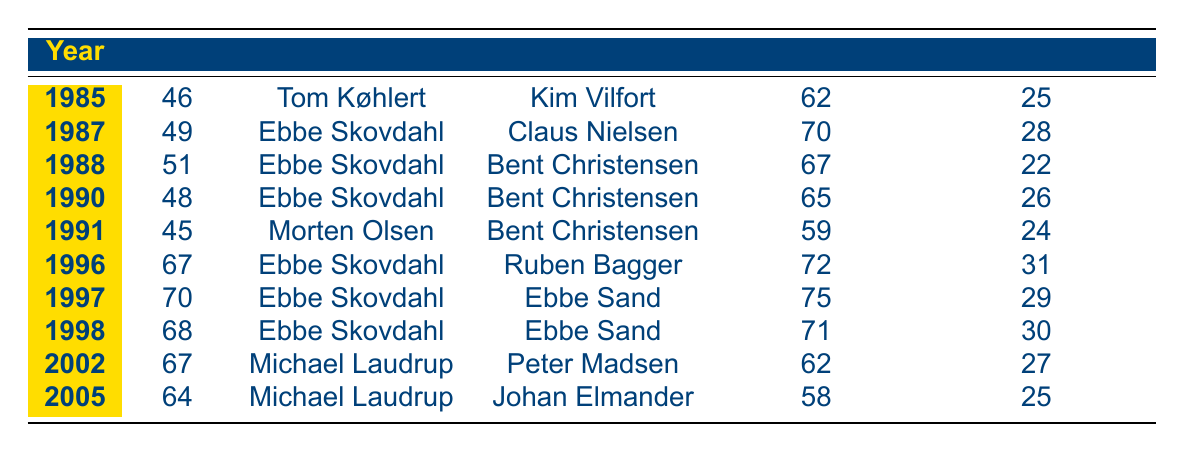What year did Brøndby IF score the highest points in the Danish Superliga? By inspecting the table, we can see the points scored for each year. The highest points are 70, which occurred in 1997.
Answer: 1997 Who was the top scorer for Brøndby IF in 1988? The table lists "Bent Christensen" as the top scorer for the year 1988 under the Top Scorer column.
Answer: Bent Christensen How many titles did Brøndby IF win under manager Ebbe Skovdahl? By counting the entries in the table, we see that under Ebbe Skovdahl, Brøndby IF won titles in 1987, 1988, 1990, 1996, 1997, and 1998, totaling six titles.
Answer: 6 What is the average number of points scored in the title-winning years? To find the average, we sum the points scored: 46 + 49 + 51 + 48 + 45 + 67 + 70 + 68 + 67 + 64 =  496. There are 10 years in total, so the average points are 496 / 10 = 49.6.
Answer: 49.6 Was the number of goals scored higher in 1996 than in 2005? In 1996, Brøndby IF scored 72 goals, while in 2005, they scored 58 goals. Since 72 is greater than 58, the answer is yes.
Answer: Yes What is the difference in points scored between the years 1985 and 1991? From the table, 1985 has 46 points and 1991 has 45 points. Therefore, the difference is 46 - 45 = 1.
Answer: 1 In which year did Brøndby IF concede the fewest goals? By reviewing the Goals Conceded column, we find that in 1988, Brøndby IF conceded only 22 goals, which is the lowest number compared to any other year in the table.
Answer: 1988 How many goals did Brøndby IF score in total under Michael Laudrup? Michael Laudrup managed Brøndby IF during the years 2002 and 2005. They scored 62 goals in 2002 and 58 goals in 2005. Summing these gives us 62 + 58 = 120 goals in total.
Answer: 120 Did Brøndby IF win more titles in the 1990s than in the 1980s? In the 1980s, Brøndby won four titles (1985, 1987, 1988, 1990) and in the 1990s they won three titles (1996, 1997, 1998). Since 4 is greater than 3, the answer is yes.
Answer: Yes 